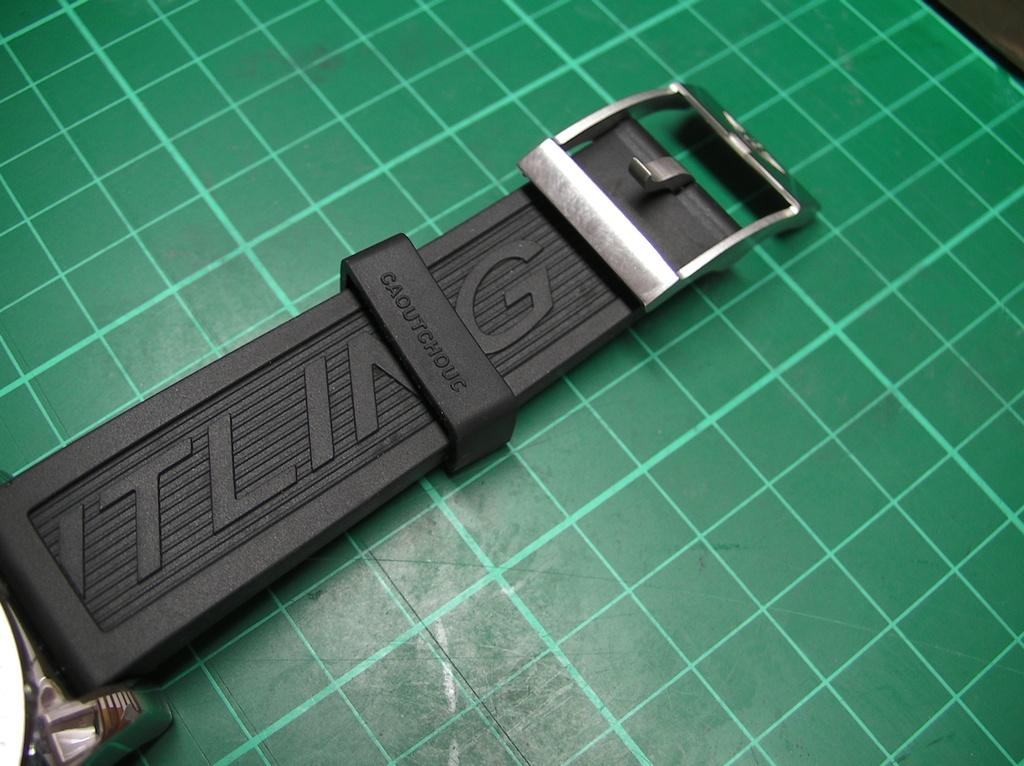<image>
Relay a brief, clear account of the picture shown. A black caoutchouc belt on a green grid counter. 